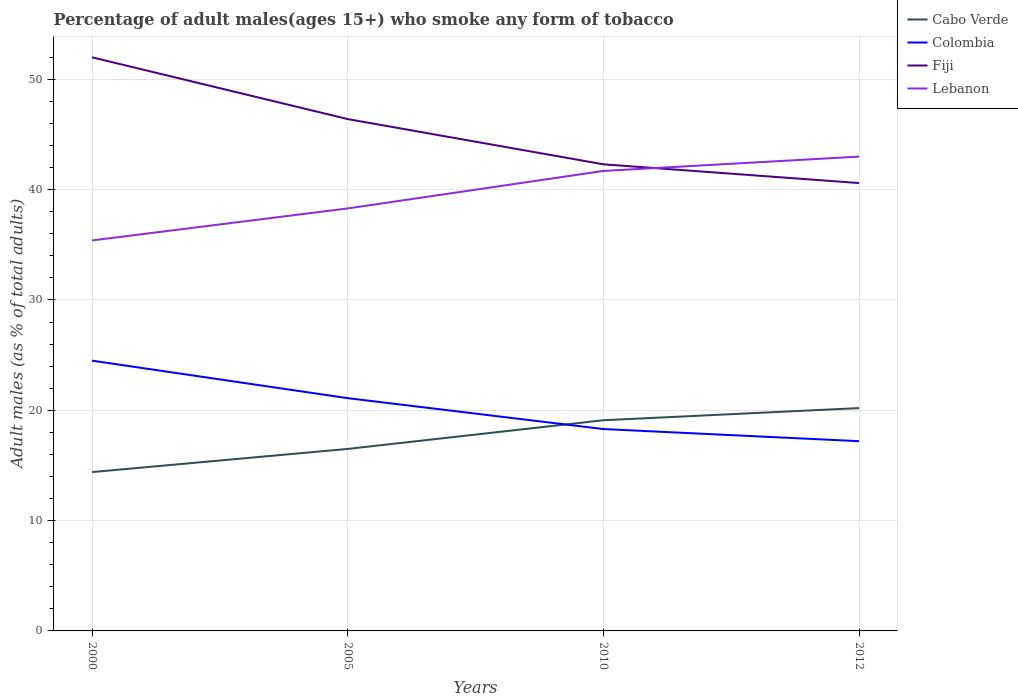Does the line corresponding to Lebanon intersect with the line corresponding to Colombia?
Provide a succinct answer. No. In which year was the percentage of adult males who smoke in Fiji maximum?
Give a very brief answer. 2012. What is the total percentage of adult males who smoke in Colombia in the graph?
Your answer should be very brief. 1.1. What is the difference between the highest and the second highest percentage of adult males who smoke in Fiji?
Ensure brevity in your answer.  11.4. Is the percentage of adult males who smoke in Cabo Verde strictly greater than the percentage of adult males who smoke in Colombia over the years?
Your answer should be very brief. No. How many lines are there?
Provide a short and direct response. 4. What is the difference between two consecutive major ticks on the Y-axis?
Your answer should be very brief. 10. Does the graph contain any zero values?
Offer a very short reply. No. Does the graph contain grids?
Provide a succinct answer. Yes. What is the title of the graph?
Your answer should be compact. Percentage of adult males(ages 15+) who smoke any form of tobacco. Does "Madagascar" appear as one of the legend labels in the graph?
Give a very brief answer. No. What is the label or title of the Y-axis?
Ensure brevity in your answer.  Adult males (as % of total adults). What is the Adult males (as % of total adults) of Colombia in 2000?
Offer a very short reply. 24.5. What is the Adult males (as % of total adults) of Fiji in 2000?
Keep it short and to the point. 52. What is the Adult males (as % of total adults) in Lebanon in 2000?
Offer a very short reply. 35.4. What is the Adult males (as % of total adults) in Cabo Verde in 2005?
Make the answer very short. 16.5. What is the Adult males (as % of total adults) in Colombia in 2005?
Your response must be concise. 21.1. What is the Adult males (as % of total adults) in Fiji in 2005?
Ensure brevity in your answer.  46.4. What is the Adult males (as % of total adults) of Lebanon in 2005?
Keep it short and to the point. 38.3. What is the Adult males (as % of total adults) in Colombia in 2010?
Your response must be concise. 18.3. What is the Adult males (as % of total adults) of Fiji in 2010?
Offer a very short reply. 42.3. What is the Adult males (as % of total adults) in Lebanon in 2010?
Provide a succinct answer. 41.7. What is the Adult males (as % of total adults) of Cabo Verde in 2012?
Make the answer very short. 20.2. What is the Adult males (as % of total adults) in Fiji in 2012?
Ensure brevity in your answer.  40.6. Across all years, what is the maximum Adult males (as % of total adults) in Cabo Verde?
Provide a succinct answer. 20.2. Across all years, what is the minimum Adult males (as % of total adults) in Cabo Verde?
Your response must be concise. 14.4. Across all years, what is the minimum Adult males (as % of total adults) in Fiji?
Offer a very short reply. 40.6. Across all years, what is the minimum Adult males (as % of total adults) of Lebanon?
Provide a short and direct response. 35.4. What is the total Adult males (as % of total adults) in Cabo Verde in the graph?
Provide a succinct answer. 70.2. What is the total Adult males (as % of total adults) in Colombia in the graph?
Your answer should be compact. 81.1. What is the total Adult males (as % of total adults) of Fiji in the graph?
Make the answer very short. 181.3. What is the total Adult males (as % of total adults) of Lebanon in the graph?
Provide a short and direct response. 158.4. What is the difference between the Adult males (as % of total adults) of Colombia in 2000 and that in 2005?
Keep it short and to the point. 3.4. What is the difference between the Adult males (as % of total adults) in Cabo Verde in 2000 and that in 2010?
Your response must be concise. -4.7. What is the difference between the Adult males (as % of total adults) in Colombia in 2000 and that in 2010?
Make the answer very short. 6.2. What is the difference between the Adult males (as % of total adults) in Fiji in 2000 and that in 2010?
Ensure brevity in your answer.  9.7. What is the difference between the Adult males (as % of total adults) in Cabo Verde in 2005 and that in 2010?
Offer a terse response. -2.6. What is the difference between the Adult males (as % of total adults) of Fiji in 2005 and that in 2010?
Give a very brief answer. 4.1. What is the difference between the Adult males (as % of total adults) in Lebanon in 2005 and that in 2010?
Offer a very short reply. -3.4. What is the difference between the Adult males (as % of total adults) of Cabo Verde in 2005 and that in 2012?
Offer a very short reply. -3.7. What is the difference between the Adult males (as % of total adults) of Lebanon in 2005 and that in 2012?
Provide a short and direct response. -4.7. What is the difference between the Adult males (as % of total adults) in Cabo Verde in 2010 and that in 2012?
Offer a very short reply. -1.1. What is the difference between the Adult males (as % of total adults) in Fiji in 2010 and that in 2012?
Keep it short and to the point. 1.7. What is the difference between the Adult males (as % of total adults) in Cabo Verde in 2000 and the Adult males (as % of total adults) in Fiji in 2005?
Provide a short and direct response. -32. What is the difference between the Adult males (as % of total adults) in Cabo Verde in 2000 and the Adult males (as % of total adults) in Lebanon in 2005?
Your answer should be very brief. -23.9. What is the difference between the Adult males (as % of total adults) in Colombia in 2000 and the Adult males (as % of total adults) in Fiji in 2005?
Your response must be concise. -21.9. What is the difference between the Adult males (as % of total adults) of Colombia in 2000 and the Adult males (as % of total adults) of Lebanon in 2005?
Your response must be concise. -13.8. What is the difference between the Adult males (as % of total adults) in Cabo Verde in 2000 and the Adult males (as % of total adults) in Fiji in 2010?
Your answer should be very brief. -27.9. What is the difference between the Adult males (as % of total adults) of Cabo Verde in 2000 and the Adult males (as % of total adults) of Lebanon in 2010?
Provide a short and direct response. -27.3. What is the difference between the Adult males (as % of total adults) in Colombia in 2000 and the Adult males (as % of total adults) in Fiji in 2010?
Provide a succinct answer. -17.8. What is the difference between the Adult males (as % of total adults) in Colombia in 2000 and the Adult males (as % of total adults) in Lebanon in 2010?
Give a very brief answer. -17.2. What is the difference between the Adult males (as % of total adults) in Fiji in 2000 and the Adult males (as % of total adults) in Lebanon in 2010?
Offer a terse response. 10.3. What is the difference between the Adult males (as % of total adults) of Cabo Verde in 2000 and the Adult males (as % of total adults) of Colombia in 2012?
Make the answer very short. -2.8. What is the difference between the Adult males (as % of total adults) of Cabo Verde in 2000 and the Adult males (as % of total adults) of Fiji in 2012?
Your response must be concise. -26.2. What is the difference between the Adult males (as % of total adults) of Cabo Verde in 2000 and the Adult males (as % of total adults) of Lebanon in 2012?
Give a very brief answer. -28.6. What is the difference between the Adult males (as % of total adults) in Colombia in 2000 and the Adult males (as % of total adults) in Fiji in 2012?
Keep it short and to the point. -16.1. What is the difference between the Adult males (as % of total adults) of Colombia in 2000 and the Adult males (as % of total adults) of Lebanon in 2012?
Your answer should be compact. -18.5. What is the difference between the Adult males (as % of total adults) in Fiji in 2000 and the Adult males (as % of total adults) in Lebanon in 2012?
Offer a terse response. 9. What is the difference between the Adult males (as % of total adults) in Cabo Verde in 2005 and the Adult males (as % of total adults) in Fiji in 2010?
Keep it short and to the point. -25.8. What is the difference between the Adult males (as % of total adults) in Cabo Verde in 2005 and the Adult males (as % of total adults) in Lebanon in 2010?
Offer a very short reply. -25.2. What is the difference between the Adult males (as % of total adults) of Colombia in 2005 and the Adult males (as % of total adults) of Fiji in 2010?
Keep it short and to the point. -21.2. What is the difference between the Adult males (as % of total adults) in Colombia in 2005 and the Adult males (as % of total adults) in Lebanon in 2010?
Your answer should be compact. -20.6. What is the difference between the Adult males (as % of total adults) in Fiji in 2005 and the Adult males (as % of total adults) in Lebanon in 2010?
Offer a terse response. 4.7. What is the difference between the Adult males (as % of total adults) of Cabo Verde in 2005 and the Adult males (as % of total adults) of Fiji in 2012?
Offer a very short reply. -24.1. What is the difference between the Adult males (as % of total adults) in Cabo Verde in 2005 and the Adult males (as % of total adults) in Lebanon in 2012?
Offer a very short reply. -26.5. What is the difference between the Adult males (as % of total adults) in Colombia in 2005 and the Adult males (as % of total adults) in Fiji in 2012?
Your answer should be compact. -19.5. What is the difference between the Adult males (as % of total adults) of Colombia in 2005 and the Adult males (as % of total adults) of Lebanon in 2012?
Offer a terse response. -21.9. What is the difference between the Adult males (as % of total adults) in Fiji in 2005 and the Adult males (as % of total adults) in Lebanon in 2012?
Ensure brevity in your answer.  3.4. What is the difference between the Adult males (as % of total adults) of Cabo Verde in 2010 and the Adult males (as % of total adults) of Fiji in 2012?
Keep it short and to the point. -21.5. What is the difference between the Adult males (as % of total adults) of Cabo Verde in 2010 and the Adult males (as % of total adults) of Lebanon in 2012?
Your answer should be very brief. -23.9. What is the difference between the Adult males (as % of total adults) in Colombia in 2010 and the Adult males (as % of total adults) in Fiji in 2012?
Your answer should be very brief. -22.3. What is the difference between the Adult males (as % of total adults) of Colombia in 2010 and the Adult males (as % of total adults) of Lebanon in 2012?
Your answer should be compact. -24.7. What is the difference between the Adult males (as % of total adults) in Fiji in 2010 and the Adult males (as % of total adults) in Lebanon in 2012?
Provide a short and direct response. -0.7. What is the average Adult males (as % of total adults) in Cabo Verde per year?
Provide a short and direct response. 17.55. What is the average Adult males (as % of total adults) of Colombia per year?
Provide a short and direct response. 20.27. What is the average Adult males (as % of total adults) in Fiji per year?
Keep it short and to the point. 45.33. What is the average Adult males (as % of total adults) of Lebanon per year?
Offer a terse response. 39.6. In the year 2000, what is the difference between the Adult males (as % of total adults) of Cabo Verde and Adult males (as % of total adults) of Colombia?
Your answer should be compact. -10.1. In the year 2000, what is the difference between the Adult males (as % of total adults) in Cabo Verde and Adult males (as % of total adults) in Fiji?
Ensure brevity in your answer.  -37.6. In the year 2000, what is the difference between the Adult males (as % of total adults) of Colombia and Adult males (as % of total adults) of Fiji?
Your answer should be very brief. -27.5. In the year 2000, what is the difference between the Adult males (as % of total adults) of Fiji and Adult males (as % of total adults) of Lebanon?
Your answer should be compact. 16.6. In the year 2005, what is the difference between the Adult males (as % of total adults) in Cabo Verde and Adult males (as % of total adults) in Colombia?
Offer a terse response. -4.6. In the year 2005, what is the difference between the Adult males (as % of total adults) of Cabo Verde and Adult males (as % of total adults) of Fiji?
Your answer should be compact. -29.9. In the year 2005, what is the difference between the Adult males (as % of total adults) in Cabo Verde and Adult males (as % of total adults) in Lebanon?
Make the answer very short. -21.8. In the year 2005, what is the difference between the Adult males (as % of total adults) in Colombia and Adult males (as % of total adults) in Fiji?
Offer a terse response. -25.3. In the year 2005, what is the difference between the Adult males (as % of total adults) of Colombia and Adult males (as % of total adults) of Lebanon?
Your answer should be compact. -17.2. In the year 2005, what is the difference between the Adult males (as % of total adults) in Fiji and Adult males (as % of total adults) in Lebanon?
Your response must be concise. 8.1. In the year 2010, what is the difference between the Adult males (as % of total adults) of Cabo Verde and Adult males (as % of total adults) of Colombia?
Your answer should be compact. 0.8. In the year 2010, what is the difference between the Adult males (as % of total adults) in Cabo Verde and Adult males (as % of total adults) in Fiji?
Keep it short and to the point. -23.2. In the year 2010, what is the difference between the Adult males (as % of total adults) of Cabo Verde and Adult males (as % of total adults) of Lebanon?
Provide a short and direct response. -22.6. In the year 2010, what is the difference between the Adult males (as % of total adults) of Colombia and Adult males (as % of total adults) of Lebanon?
Your answer should be compact. -23.4. In the year 2012, what is the difference between the Adult males (as % of total adults) in Cabo Verde and Adult males (as % of total adults) in Colombia?
Give a very brief answer. 3. In the year 2012, what is the difference between the Adult males (as % of total adults) of Cabo Verde and Adult males (as % of total adults) of Fiji?
Offer a very short reply. -20.4. In the year 2012, what is the difference between the Adult males (as % of total adults) in Cabo Verde and Adult males (as % of total adults) in Lebanon?
Your answer should be very brief. -22.8. In the year 2012, what is the difference between the Adult males (as % of total adults) in Colombia and Adult males (as % of total adults) in Fiji?
Your answer should be compact. -23.4. In the year 2012, what is the difference between the Adult males (as % of total adults) of Colombia and Adult males (as % of total adults) of Lebanon?
Keep it short and to the point. -25.8. What is the ratio of the Adult males (as % of total adults) of Cabo Verde in 2000 to that in 2005?
Your response must be concise. 0.87. What is the ratio of the Adult males (as % of total adults) of Colombia in 2000 to that in 2005?
Ensure brevity in your answer.  1.16. What is the ratio of the Adult males (as % of total adults) of Fiji in 2000 to that in 2005?
Offer a terse response. 1.12. What is the ratio of the Adult males (as % of total adults) of Lebanon in 2000 to that in 2005?
Offer a very short reply. 0.92. What is the ratio of the Adult males (as % of total adults) of Cabo Verde in 2000 to that in 2010?
Keep it short and to the point. 0.75. What is the ratio of the Adult males (as % of total adults) in Colombia in 2000 to that in 2010?
Your answer should be compact. 1.34. What is the ratio of the Adult males (as % of total adults) of Fiji in 2000 to that in 2010?
Ensure brevity in your answer.  1.23. What is the ratio of the Adult males (as % of total adults) of Lebanon in 2000 to that in 2010?
Give a very brief answer. 0.85. What is the ratio of the Adult males (as % of total adults) in Cabo Verde in 2000 to that in 2012?
Offer a very short reply. 0.71. What is the ratio of the Adult males (as % of total adults) in Colombia in 2000 to that in 2012?
Offer a terse response. 1.42. What is the ratio of the Adult males (as % of total adults) in Fiji in 2000 to that in 2012?
Your answer should be compact. 1.28. What is the ratio of the Adult males (as % of total adults) in Lebanon in 2000 to that in 2012?
Your answer should be very brief. 0.82. What is the ratio of the Adult males (as % of total adults) in Cabo Verde in 2005 to that in 2010?
Offer a terse response. 0.86. What is the ratio of the Adult males (as % of total adults) in Colombia in 2005 to that in 2010?
Ensure brevity in your answer.  1.15. What is the ratio of the Adult males (as % of total adults) of Fiji in 2005 to that in 2010?
Provide a succinct answer. 1.1. What is the ratio of the Adult males (as % of total adults) in Lebanon in 2005 to that in 2010?
Your answer should be very brief. 0.92. What is the ratio of the Adult males (as % of total adults) in Cabo Verde in 2005 to that in 2012?
Provide a succinct answer. 0.82. What is the ratio of the Adult males (as % of total adults) of Colombia in 2005 to that in 2012?
Provide a succinct answer. 1.23. What is the ratio of the Adult males (as % of total adults) of Fiji in 2005 to that in 2012?
Offer a terse response. 1.14. What is the ratio of the Adult males (as % of total adults) in Lebanon in 2005 to that in 2012?
Give a very brief answer. 0.89. What is the ratio of the Adult males (as % of total adults) of Cabo Verde in 2010 to that in 2012?
Provide a short and direct response. 0.95. What is the ratio of the Adult males (as % of total adults) in Colombia in 2010 to that in 2012?
Your response must be concise. 1.06. What is the ratio of the Adult males (as % of total adults) of Fiji in 2010 to that in 2012?
Offer a very short reply. 1.04. What is the ratio of the Adult males (as % of total adults) in Lebanon in 2010 to that in 2012?
Your answer should be very brief. 0.97. What is the difference between the highest and the second highest Adult males (as % of total adults) of Cabo Verde?
Provide a short and direct response. 1.1. What is the difference between the highest and the second highest Adult males (as % of total adults) of Lebanon?
Your answer should be compact. 1.3. What is the difference between the highest and the lowest Adult males (as % of total adults) in Lebanon?
Provide a short and direct response. 7.6. 